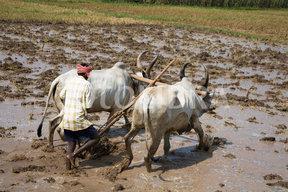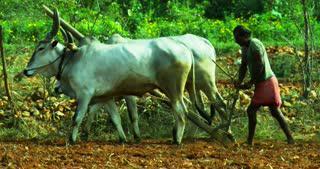The first image is the image on the left, the second image is the image on the right. Considering the images on both sides, is "The left and right image contains the same number of ox pulling a tilt guided by at man and one of the men is not wearing a hat." valid? Answer yes or no. Yes. The first image is the image on the left, the second image is the image on the right. Considering the images on both sides, is "Each image shows one person behind two hitched white oxen, and the right image shows oxen moving leftward." valid? Answer yes or no. Yes. 